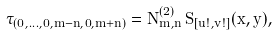Convert formula to latex. <formula><loc_0><loc_0><loc_500><loc_500>\tau _ { ( 0 , \dots , 0 , m - n , 0 , m + n ) } = N ^ { ( 2 ) } _ { m , n } \, S _ { [ u ! , v ! ] } ( x , y ) ,</formula> 